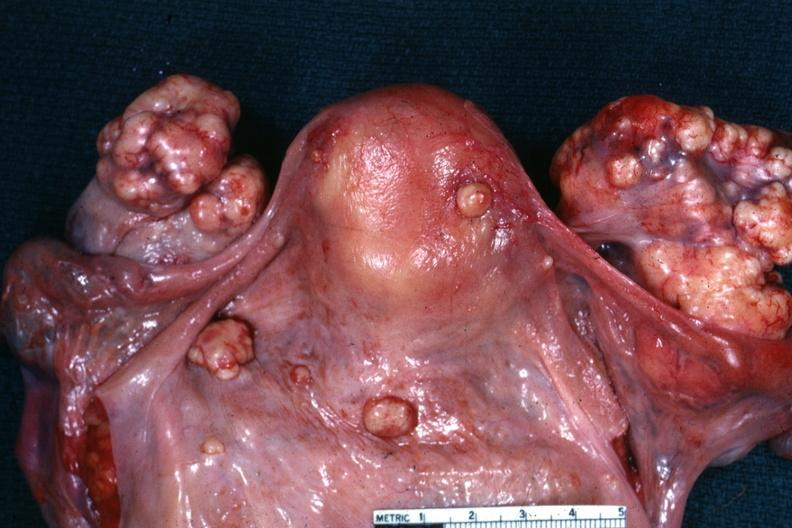what is this?
Answer the question using a single word or phrase. True bilateral krukenberg 